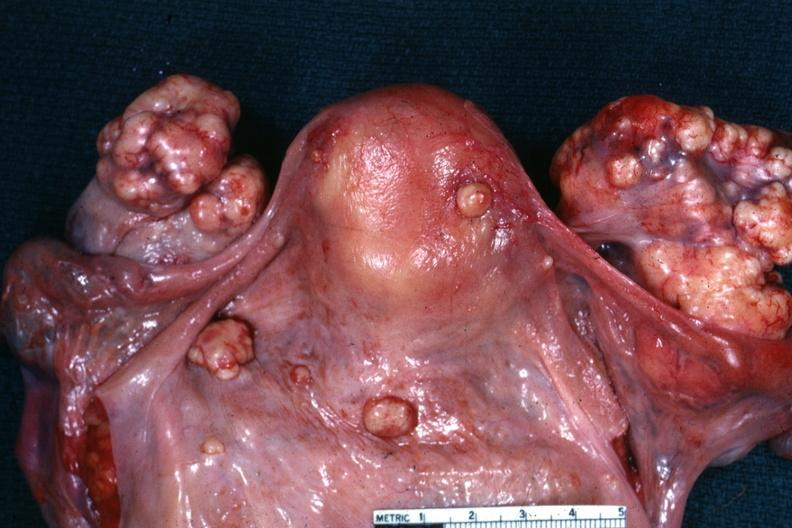what is this?
Answer the question using a single word or phrase. True bilateral krukenberg 